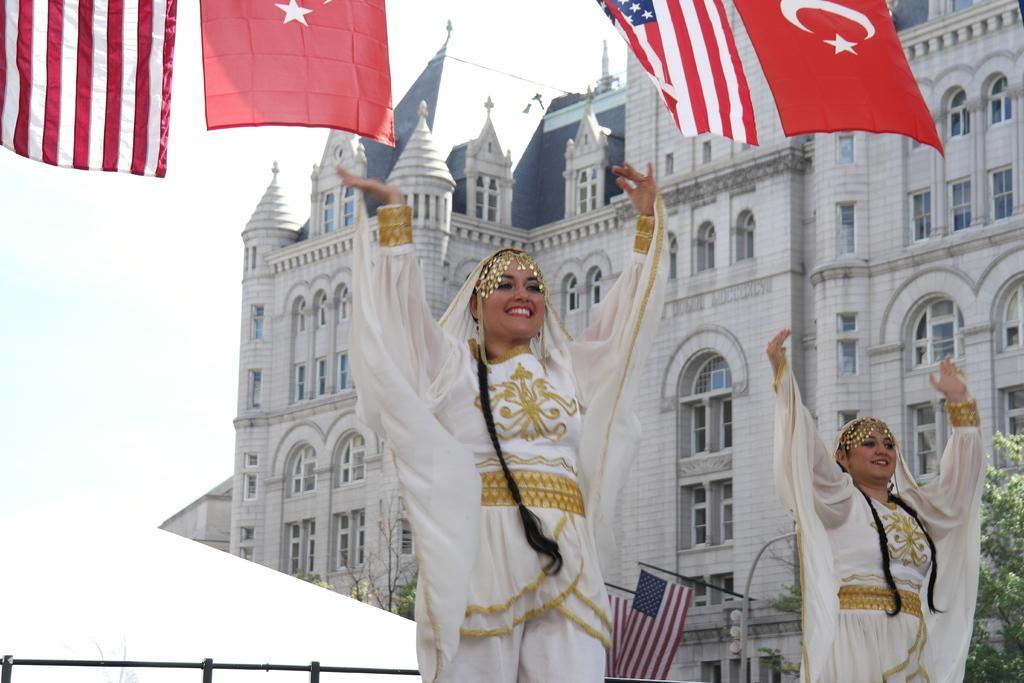Can you describe this image briefly? In the picture,there are two women dancing by wearing white dress,above the women there are four flags of two countries and behind the flag there is a big building. 